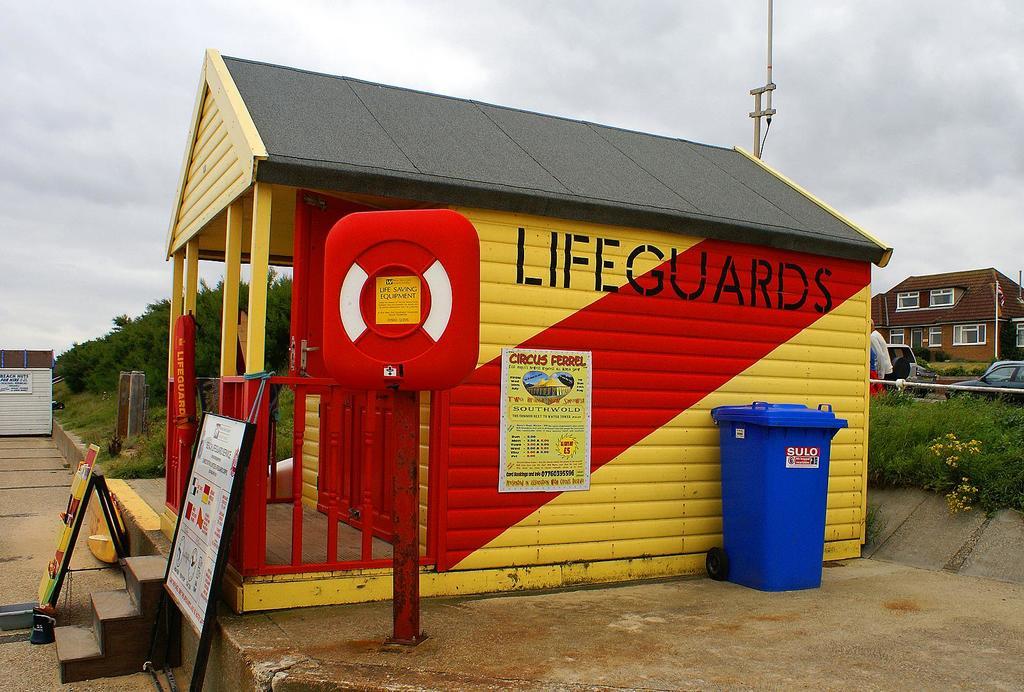Who works in this hut?
Provide a succinct answer. Lifeguards. What is the poster for?
Ensure brevity in your answer.  Circus ferrel. 